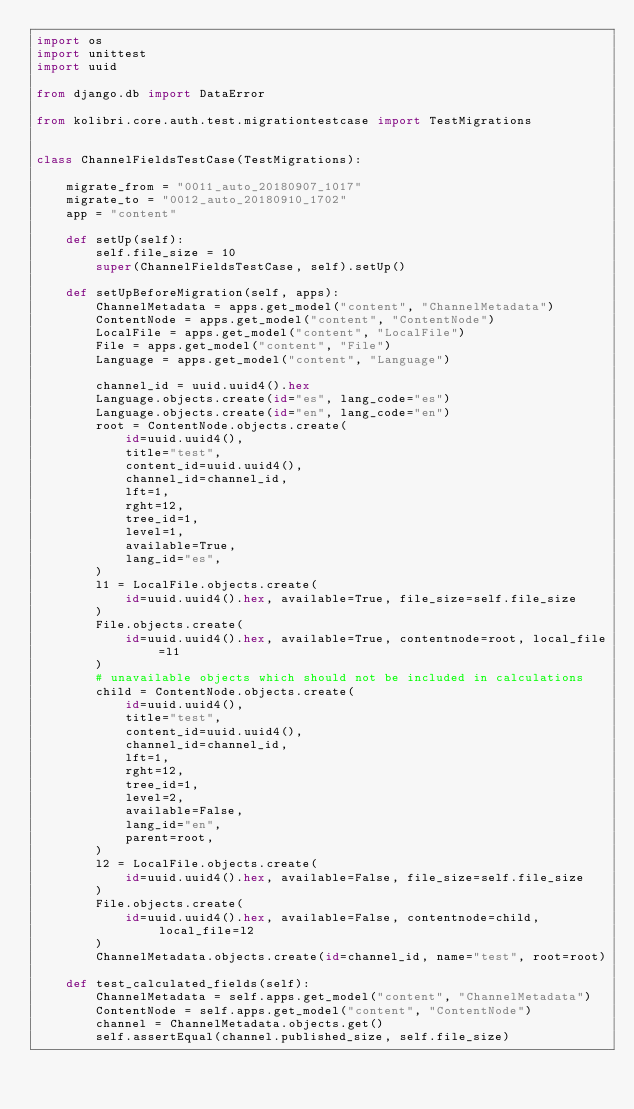Convert code to text. <code><loc_0><loc_0><loc_500><loc_500><_Python_>import os
import unittest
import uuid

from django.db import DataError

from kolibri.core.auth.test.migrationtestcase import TestMigrations


class ChannelFieldsTestCase(TestMigrations):

    migrate_from = "0011_auto_20180907_1017"
    migrate_to = "0012_auto_20180910_1702"
    app = "content"

    def setUp(self):
        self.file_size = 10
        super(ChannelFieldsTestCase, self).setUp()

    def setUpBeforeMigration(self, apps):
        ChannelMetadata = apps.get_model("content", "ChannelMetadata")
        ContentNode = apps.get_model("content", "ContentNode")
        LocalFile = apps.get_model("content", "LocalFile")
        File = apps.get_model("content", "File")
        Language = apps.get_model("content", "Language")

        channel_id = uuid.uuid4().hex
        Language.objects.create(id="es", lang_code="es")
        Language.objects.create(id="en", lang_code="en")
        root = ContentNode.objects.create(
            id=uuid.uuid4(),
            title="test",
            content_id=uuid.uuid4(),
            channel_id=channel_id,
            lft=1,
            rght=12,
            tree_id=1,
            level=1,
            available=True,
            lang_id="es",
        )
        l1 = LocalFile.objects.create(
            id=uuid.uuid4().hex, available=True, file_size=self.file_size
        )
        File.objects.create(
            id=uuid.uuid4().hex, available=True, contentnode=root, local_file=l1
        )
        # unavailable objects which should not be included in calculations
        child = ContentNode.objects.create(
            id=uuid.uuid4(),
            title="test",
            content_id=uuid.uuid4(),
            channel_id=channel_id,
            lft=1,
            rght=12,
            tree_id=1,
            level=2,
            available=False,
            lang_id="en",
            parent=root,
        )
        l2 = LocalFile.objects.create(
            id=uuid.uuid4().hex, available=False, file_size=self.file_size
        )
        File.objects.create(
            id=uuid.uuid4().hex, available=False, contentnode=child, local_file=l2
        )
        ChannelMetadata.objects.create(id=channel_id, name="test", root=root)

    def test_calculated_fields(self):
        ChannelMetadata = self.apps.get_model("content", "ChannelMetadata")
        ContentNode = self.apps.get_model("content", "ContentNode")
        channel = ChannelMetadata.objects.get()
        self.assertEqual(channel.published_size, self.file_size)</code> 